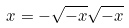<formula> <loc_0><loc_0><loc_500><loc_500>x = - \sqrt { - x } \sqrt { - x }</formula> 